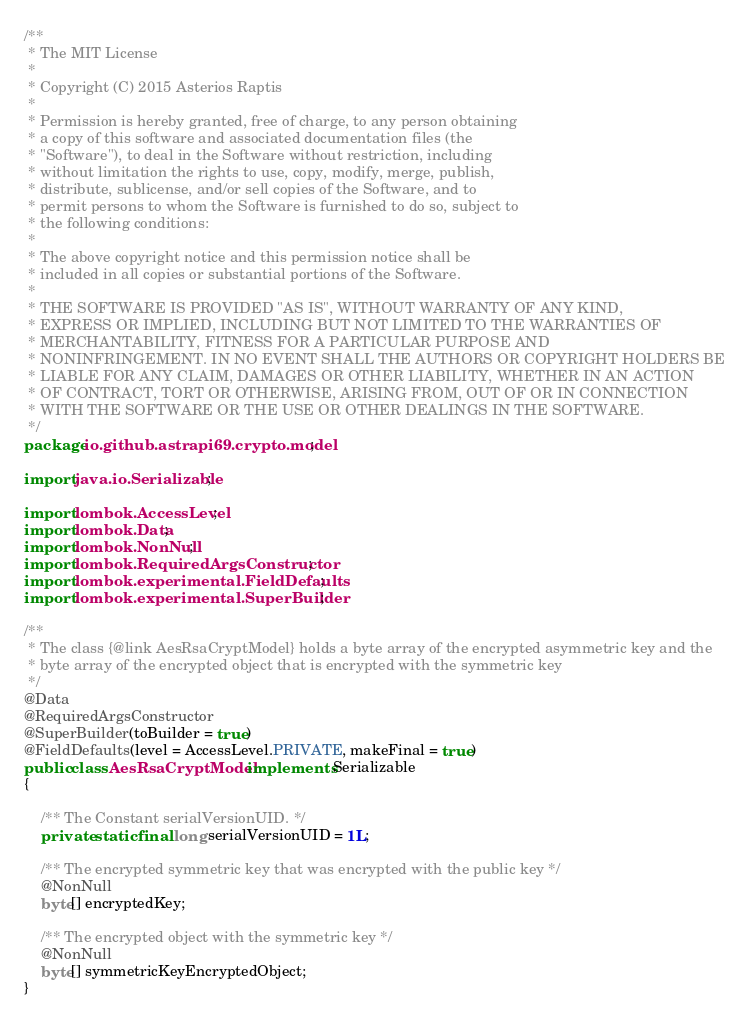Convert code to text. <code><loc_0><loc_0><loc_500><loc_500><_Java_>/**
 * The MIT License
 *
 * Copyright (C) 2015 Asterios Raptis
 *
 * Permission is hereby granted, free of charge, to any person obtaining
 * a copy of this software and associated documentation files (the
 * "Software"), to deal in the Software without restriction, including
 * without limitation the rights to use, copy, modify, merge, publish,
 * distribute, sublicense, and/or sell copies of the Software, and to
 * permit persons to whom the Software is furnished to do so, subject to
 * the following conditions:
 *
 * The above copyright notice and this permission notice shall be
 * included in all copies or substantial portions of the Software.
 *
 * THE SOFTWARE IS PROVIDED "AS IS", WITHOUT WARRANTY OF ANY KIND,
 * EXPRESS OR IMPLIED, INCLUDING BUT NOT LIMITED TO THE WARRANTIES OF
 * MERCHANTABILITY, FITNESS FOR A PARTICULAR PURPOSE AND
 * NONINFRINGEMENT. IN NO EVENT SHALL THE AUTHORS OR COPYRIGHT HOLDERS BE
 * LIABLE FOR ANY CLAIM, DAMAGES OR OTHER LIABILITY, WHETHER IN AN ACTION
 * OF CONTRACT, TORT OR OTHERWISE, ARISING FROM, OUT OF OR IN CONNECTION
 * WITH THE SOFTWARE OR THE USE OR OTHER DEALINGS IN THE SOFTWARE.
 */
package io.github.astrapi69.crypto.model;

import java.io.Serializable;

import lombok.AccessLevel;
import lombok.Data;
import lombok.NonNull;
import lombok.RequiredArgsConstructor;
import lombok.experimental.FieldDefaults;
import lombok.experimental.SuperBuilder;

/**
 * The class {@link AesRsaCryptModel} holds a byte array of the encrypted asymmetric key and the
 * byte array of the encrypted object that is encrypted with the symmetric key
 */
@Data
@RequiredArgsConstructor
@SuperBuilder(toBuilder = true)
@FieldDefaults(level = AccessLevel.PRIVATE, makeFinal = true)
public class AesRsaCryptModel implements Serializable
{

	/** The Constant serialVersionUID. */
	private static final long serialVersionUID = 1L;

	/** The encrypted symmetric key that was encrypted with the public key */
	@NonNull
	byte[] encryptedKey;

	/** The encrypted object with the symmetric key */
	@NonNull
	byte[] symmetricKeyEncryptedObject;
}
</code> 